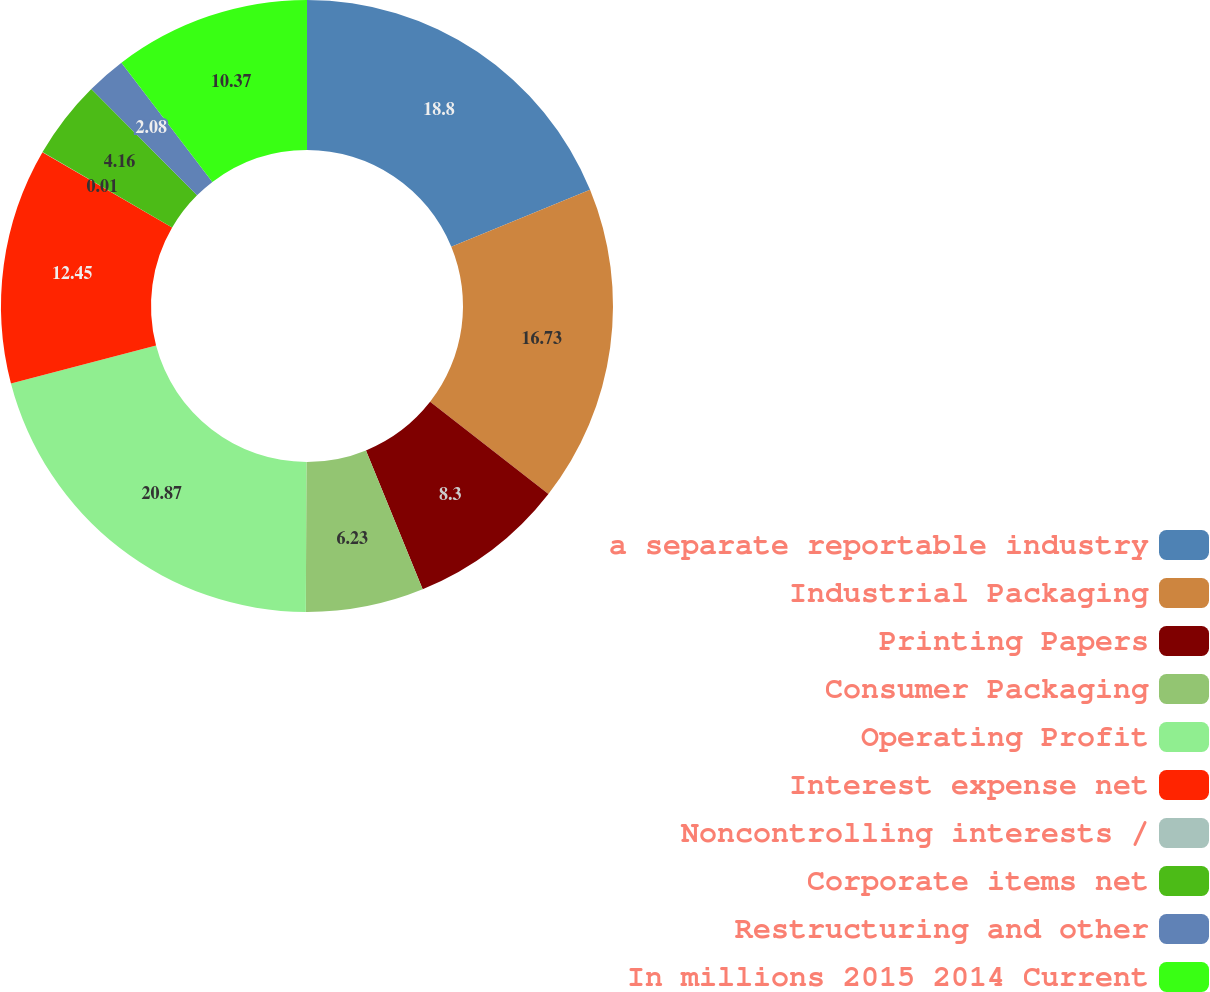Convert chart to OTSL. <chart><loc_0><loc_0><loc_500><loc_500><pie_chart><fcel>a separate reportable industry<fcel>Industrial Packaging<fcel>Printing Papers<fcel>Consumer Packaging<fcel>Operating Profit<fcel>Interest expense net<fcel>Noncontrolling interests /<fcel>Corporate items net<fcel>Restructuring and other<fcel>In millions 2015 2014 Current<nl><fcel>18.8%<fcel>16.73%<fcel>8.3%<fcel>6.23%<fcel>20.87%<fcel>12.45%<fcel>0.01%<fcel>4.16%<fcel>2.08%<fcel>10.37%<nl></chart> 